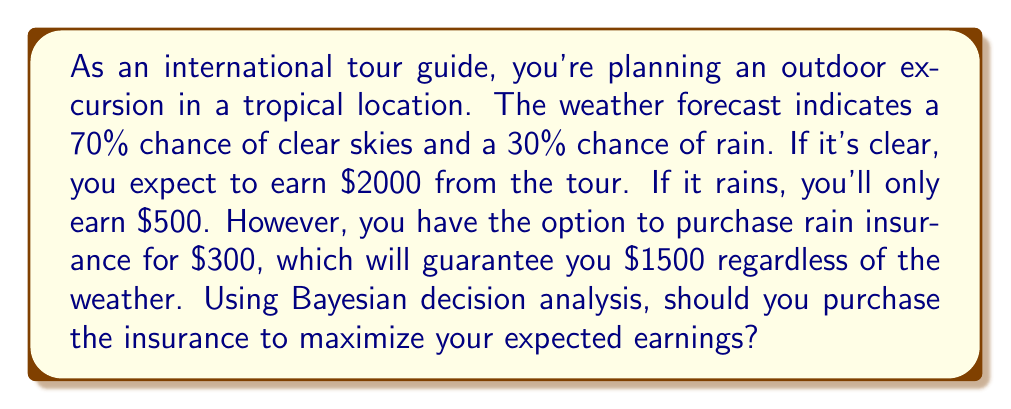What is the answer to this math problem? Let's approach this problem step-by-step using Bayesian decision analysis:

1) First, let's define our decision alternatives:
   A1: Don't purchase insurance
   A2: Purchase insurance

2) Next, let's identify the possible states of nature:
   S1: Clear weather (probability = 0.7)
   S2: Rainy weather (probability = 0.3)

3) Now, let's create a payoff table:

   $$\begin{array}{c|cc}
   & \text{Clear (0.7)} & \text{Rain (0.3)} \\
   \hline
   \text{No Insurance} & 2000 & 500 \\
   \text{Insurance} & 1500-300=1200 & 1500-300=1200
   \end{array}$$

4) Calculate the expected value for each decision:

   E(A1) = Expected value without insurance
   $$E(A1) = 0.7 \times 2000 + 0.3 \times 500 = 1400 + 150 = 1550$$

   E(A2) = Expected value with insurance
   $$E(A2) = 0.7 \times 1200 + 0.3 \times 1200 = 840 + 360 = 1200$$

5) Compare the expected values:

   E(A1) = $1550
   E(A2) = $1200

   The expected value of not purchasing insurance (A1) is higher.

6) Decision rule: Choose the alternative with the highest expected value.

Therefore, to maximize expected earnings, you should not purchase the insurance.
Answer: Do not purchase the insurance. The expected earnings without insurance ($1550) are higher than with insurance ($1200). 